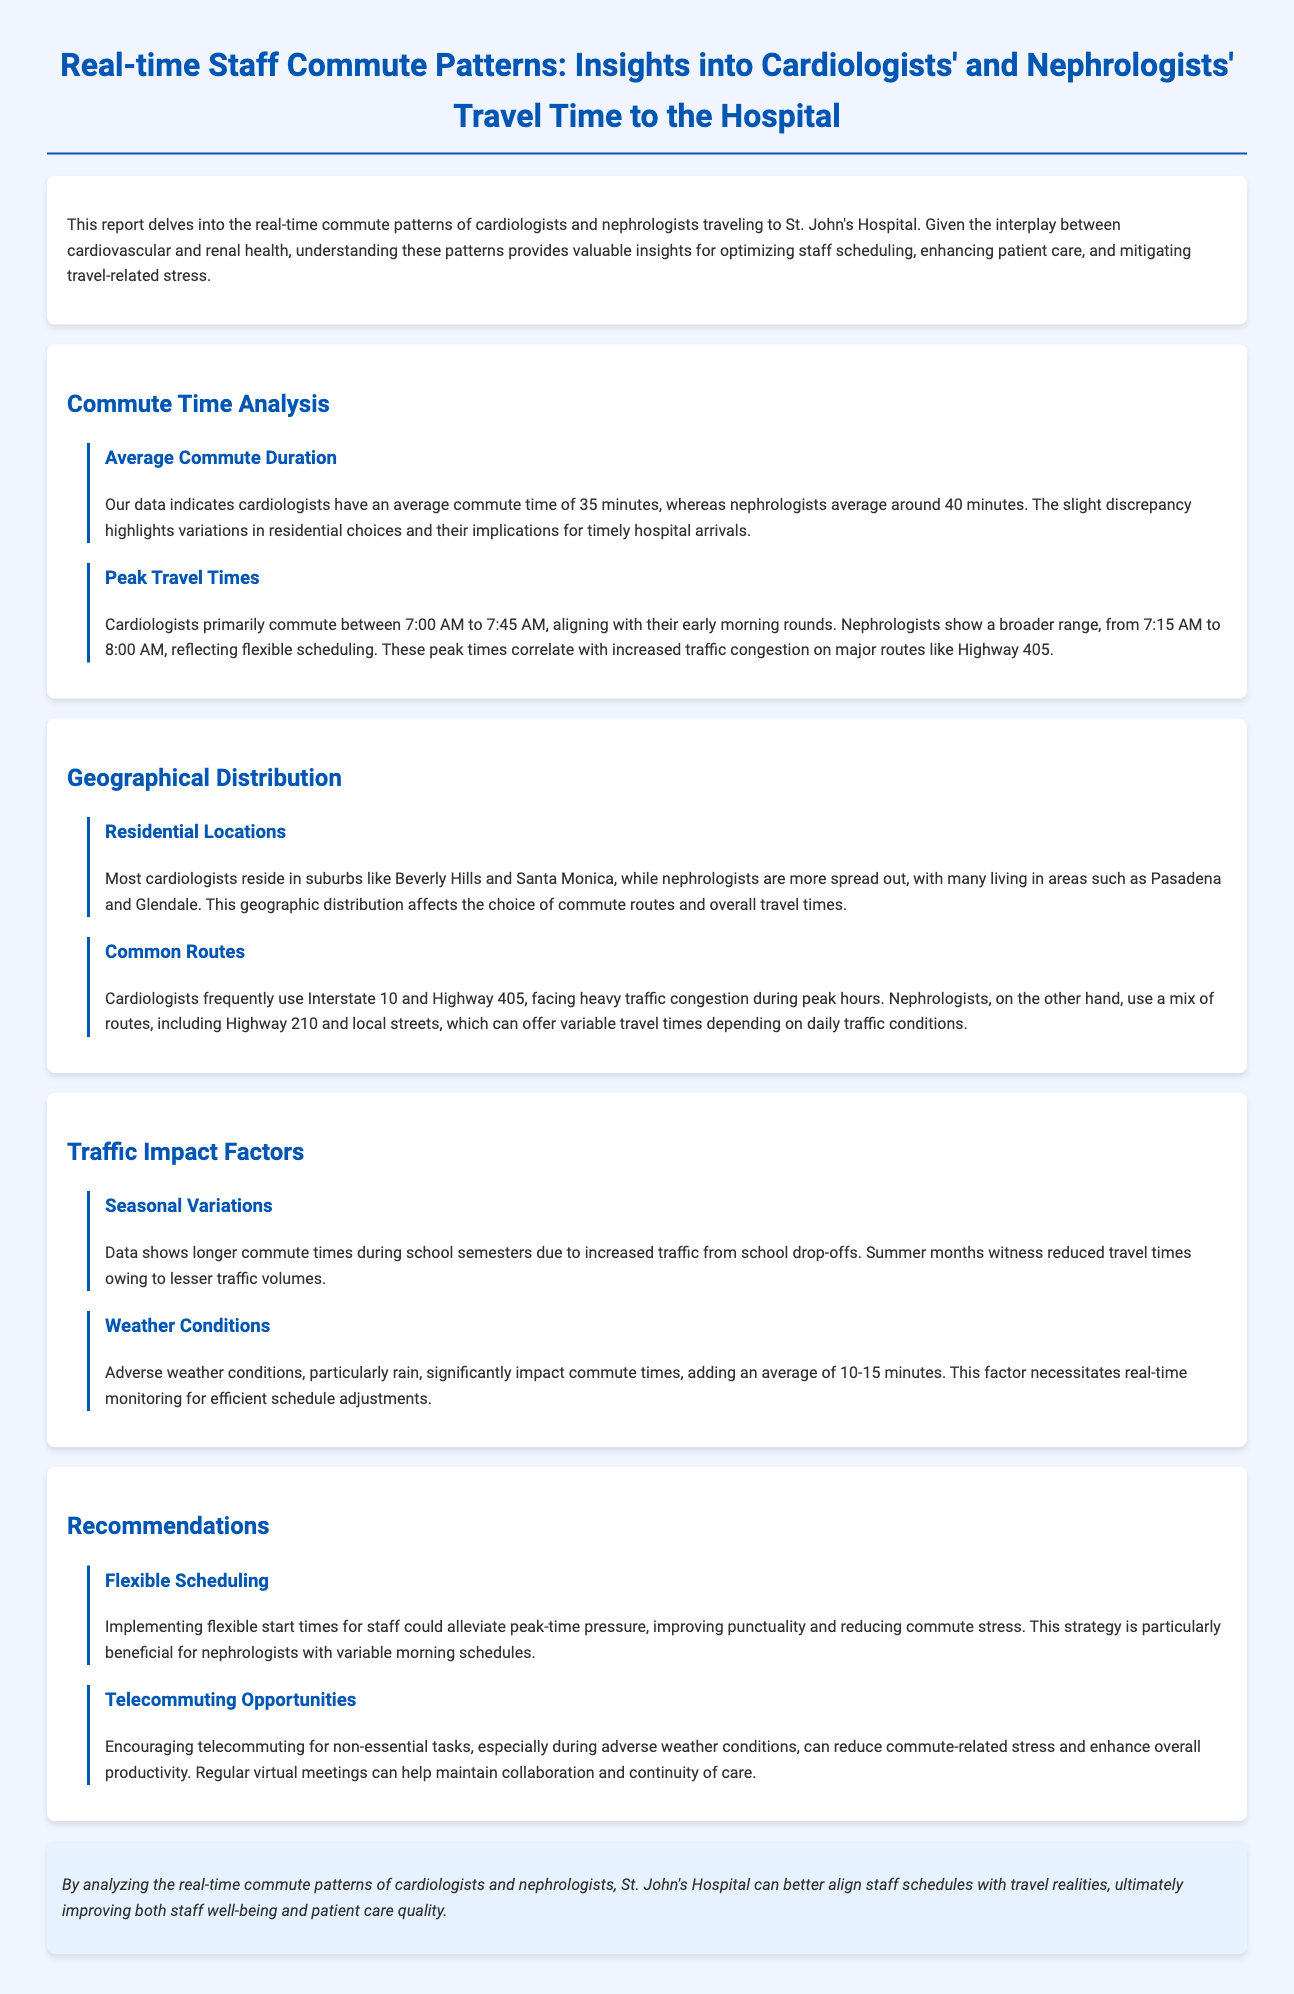what is the average commute time for cardiologists? The average commute time for cardiologists is mentioned in the document.
Answer: 35 minutes what is the average commute time for nephrologists? The document states the average commute time for nephrologists.
Answer: 40 minutes what are the peak travel times for cardiologists? The document outlines the peak travel times for cardiologists.
Answer: 7:00 AM to 7:45 AM where do most cardiologists reside according to the report? The document specifies the residential locations of cardiologists.
Answer: Beverly Hills and Santa Monica which routes do cardiologists frequently use? The document lists the common routes used by cardiologists.
Answer: Interstate 10 and Highway 405 how do adverse weather conditions impact commute times? The report discusses the effect of weather on travel times.
Answer: 10-15 minutes what is one recommendation for improving staff punctuality? The document provides recommendations for improving commuting efficiency.
Answer: Flexible scheduling what is one factor that causes longer commute times? The report mentions factors influencing commute duration.
Answer: Seasonal variations how can telecommuting benefit staff during bad weather? The document discusses the advantages of telecommuting in certain conditions.
Answer: Reduce commute-related stress 